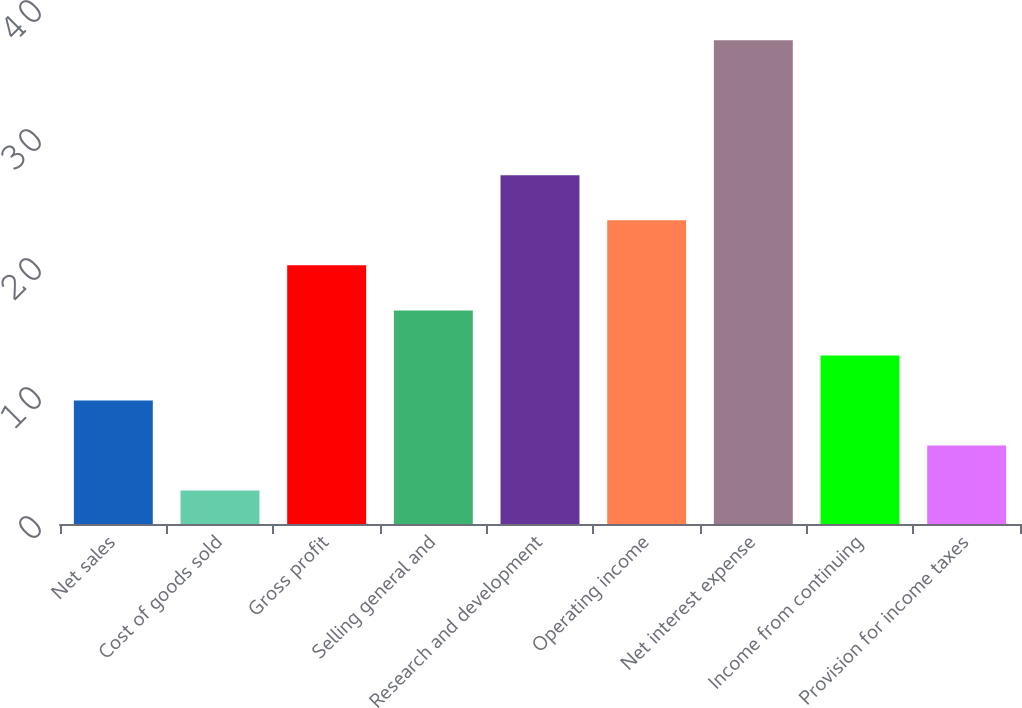<chart> <loc_0><loc_0><loc_500><loc_500><bar_chart><fcel>Net sales<fcel>Cost of goods sold<fcel>Gross profit<fcel>Selling general and<fcel>Research and development<fcel>Operating income<fcel>Net interest expense<fcel>Income from continuing<fcel>Provision for income taxes<nl><fcel>9.58<fcel>2.6<fcel>20.05<fcel>16.56<fcel>27.03<fcel>23.54<fcel>37.5<fcel>13.07<fcel>6.09<nl></chart> 